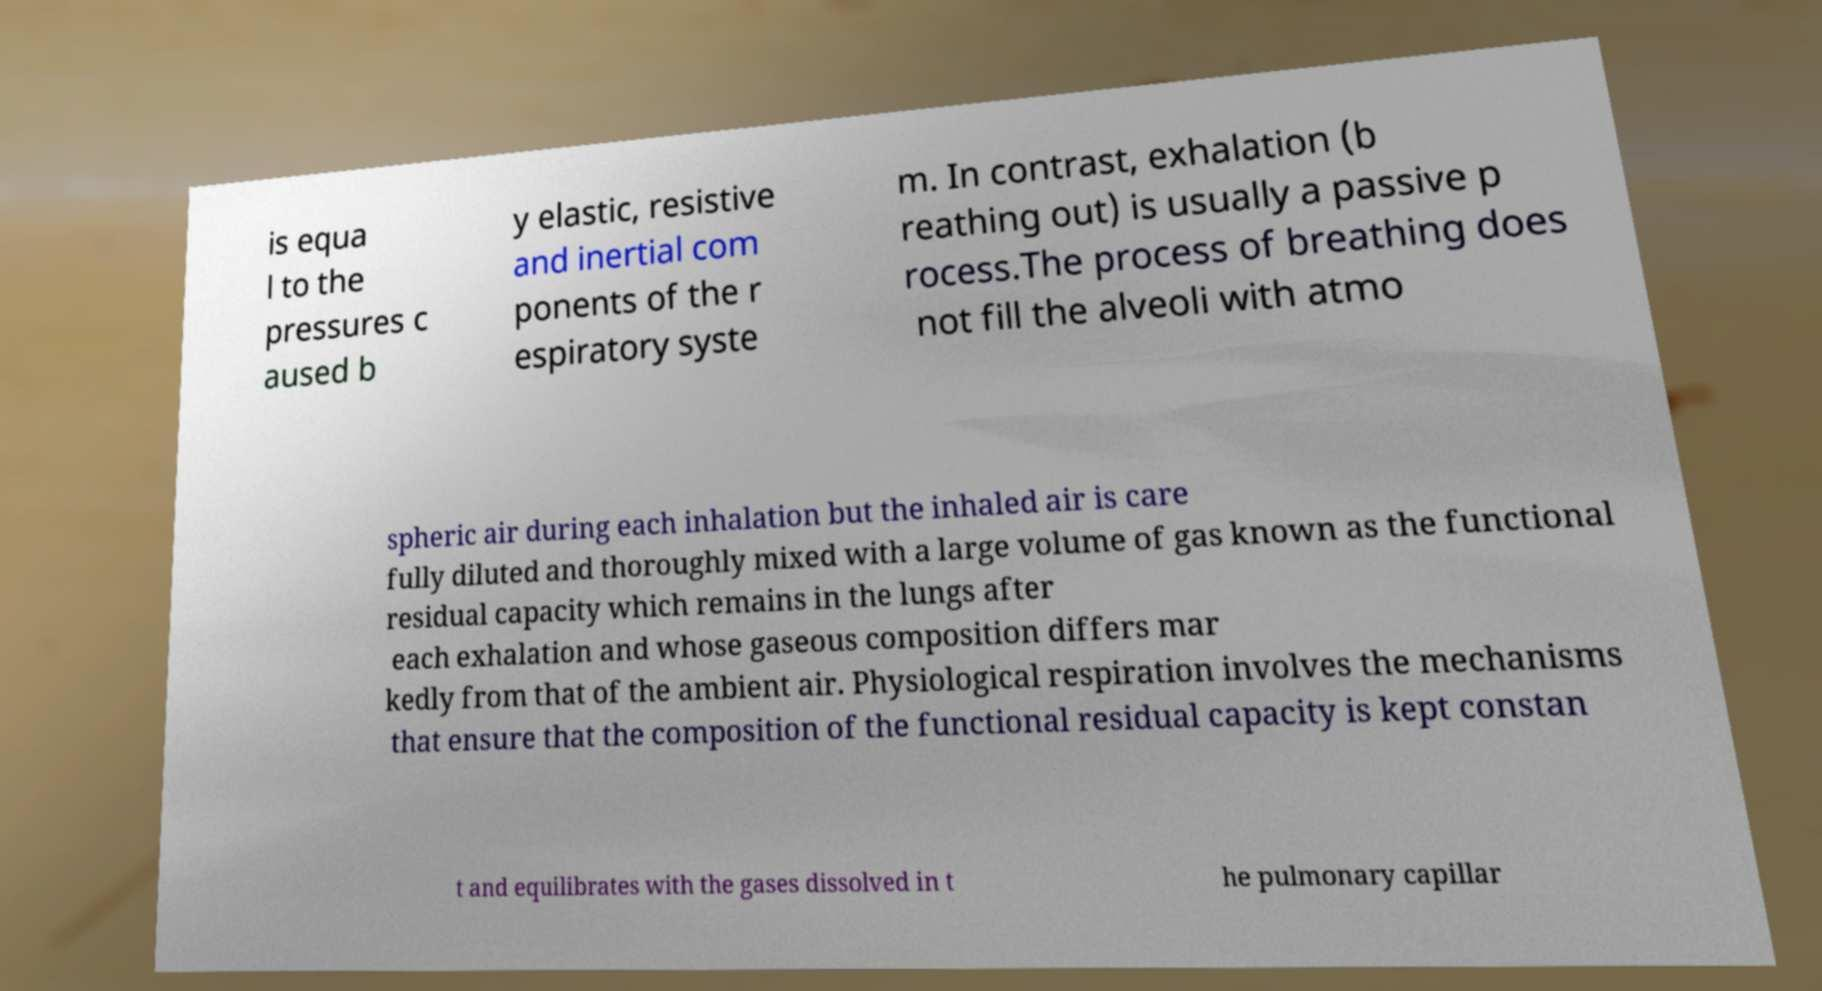Can you accurately transcribe the text from the provided image for me? is equa l to the pressures c aused b y elastic, resistive and inertial com ponents of the r espiratory syste m. In contrast, exhalation (b reathing out) is usually a passive p rocess.The process of breathing does not fill the alveoli with atmo spheric air during each inhalation but the inhaled air is care fully diluted and thoroughly mixed with a large volume of gas known as the functional residual capacity which remains in the lungs after each exhalation and whose gaseous composition differs mar kedly from that of the ambient air. Physiological respiration involves the mechanisms that ensure that the composition of the functional residual capacity is kept constan t and equilibrates with the gases dissolved in t he pulmonary capillar 